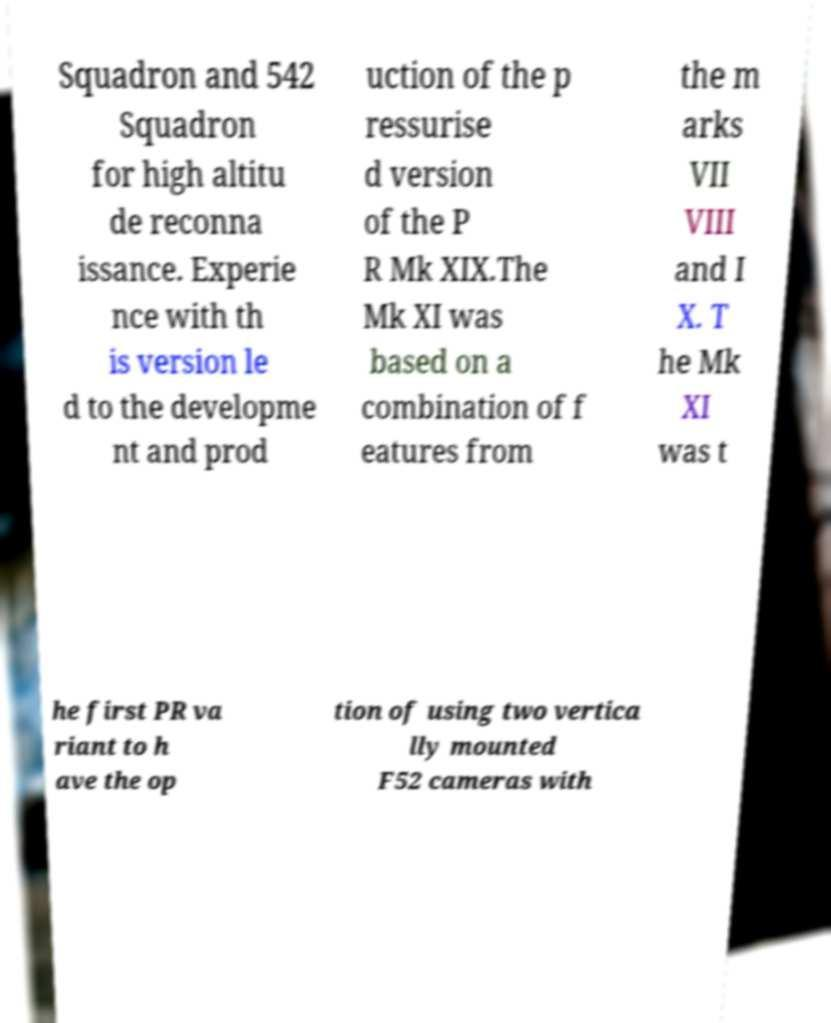Could you extract and type out the text from this image? Squadron and 542 Squadron for high altitu de reconna issance. Experie nce with th is version le d to the developme nt and prod uction of the p ressurise d version of the P R Mk XIX.The Mk XI was based on a combination of f eatures from the m arks VII VIII and I X. T he Mk XI was t he first PR va riant to h ave the op tion of using two vertica lly mounted F52 cameras with 